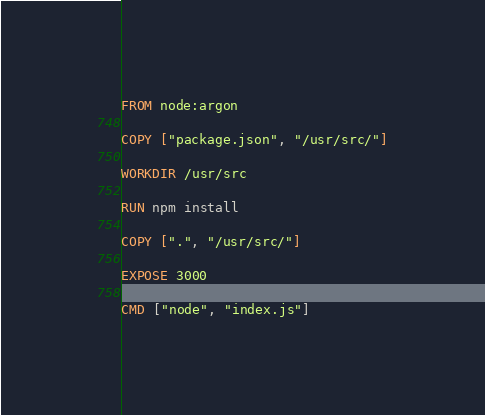<code> <loc_0><loc_0><loc_500><loc_500><_Dockerfile_>FROM node:argon

COPY ["package.json", "/usr/src/"]

WORKDIR /usr/src

RUN npm install

COPY [".", "/usr/src/"]

EXPOSE 3000

CMD ["node", "index.js"]
</code> 